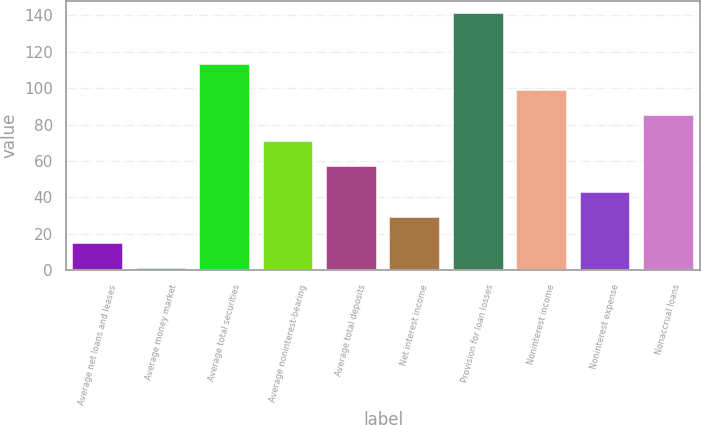<chart> <loc_0><loc_0><loc_500><loc_500><bar_chart><fcel>Average net loans and leases<fcel>Average money market<fcel>Average total securities<fcel>Average noninterest-bearing<fcel>Average total deposits<fcel>Net interest income<fcel>Provision for loan losses<fcel>Noninterest income<fcel>Noninterest expense<fcel>Nonaccrual loans<nl><fcel>15<fcel>1<fcel>113<fcel>71<fcel>57<fcel>29<fcel>141<fcel>99<fcel>43<fcel>85<nl></chart> 